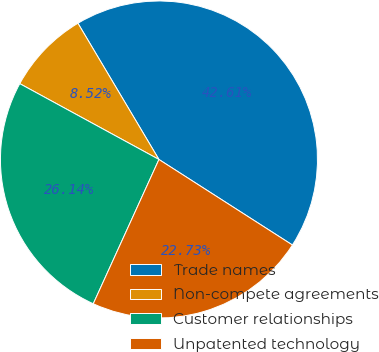Convert chart to OTSL. <chart><loc_0><loc_0><loc_500><loc_500><pie_chart><fcel>Trade names<fcel>Non-compete agreements<fcel>Customer relationships<fcel>Unpatented technology<nl><fcel>42.61%<fcel>8.52%<fcel>26.14%<fcel>22.73%<nl></chart> 